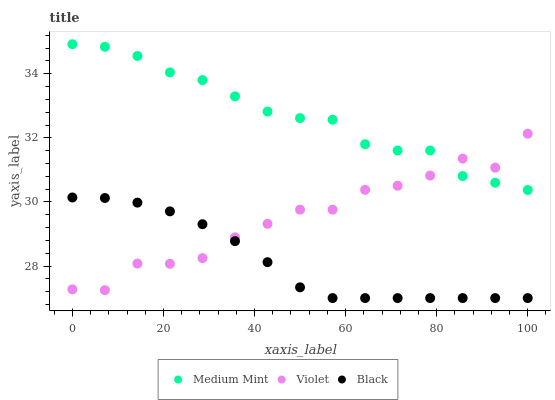Does Black have the minimum area under the curve?
Answer yes or no. Yes. Does Medium Mint have the maximum area under the curve?
Answer yes or no. Yes. Does Violet have the minimum area under the curve?
Answer yes or no. No. Does Violet have the maximum area under the curve?
Answer yes or no. No. Is Black the smoothest?
Answer yes or no. Yes. Is Violet the roughest?
Answer yes or no. Yes. Is Violet the smoothest?
Answer yes or no. No. Is Black the roughest?
Answer yes or no. No. Does Black have the lowest value?
Answer yes or no. Yes. Does Violet have the lowest value?
Answer yes or no. No. Does Medium Mint have the highest value?
Answer yes or no. Yes. Does Violet have the highest value?
Answer yes or no. No. Is Black less than Medium Mint?
Answer yes or no. Yes. Is Medium Mint greater than Black?
Answer yes or no. Yes. Does Violet intersect Medium Mint?
Answer yes or no. Yes. Is Violet less than Medium Mint?
Answer yes or no. No. Is Violet greater than Medium Mint?
Answer yes or no. No. Does Black intersect Medium Mint?
Answer yes or no. No. 